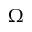Convert formula to latex. <formula><loc_0><loc_0><loc_500><loc_500>\Omega</formula> 